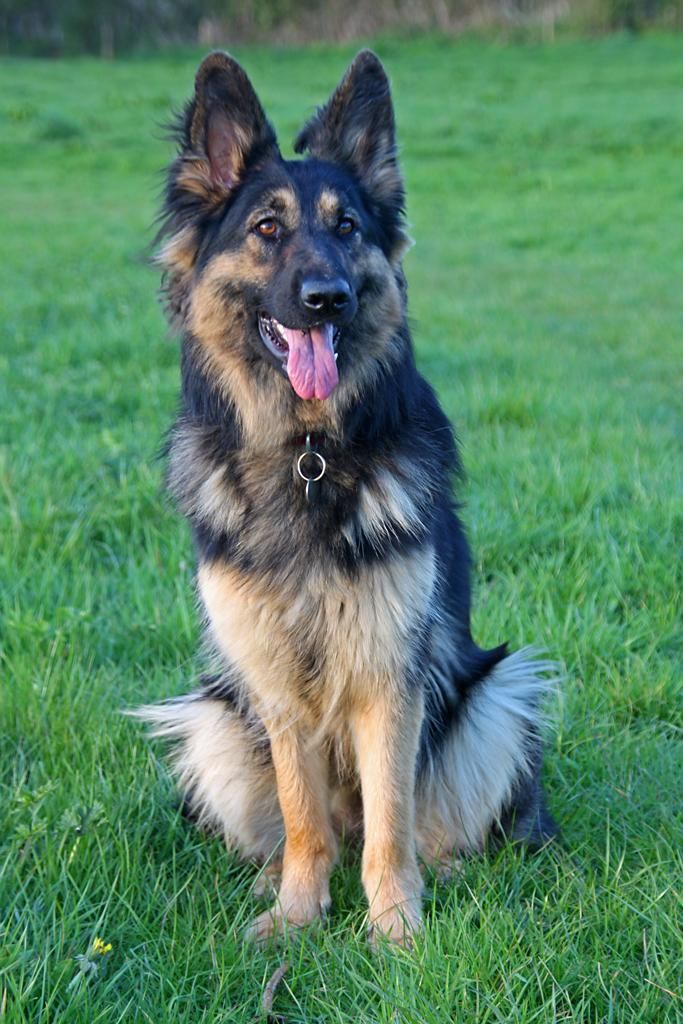What animal is present in the image? There is a dog in the image. What is the dog doing in the image? The dog is sitting on the grass. Can you describe the color of the dog? The dog is in black and cream color. What might be visible in the background of the image? There might be trees in the background of the image. Where is the tub located in the image? There is no tub present in the image. Can you see a giraffe in the image? There is no giraffe present in the image. 